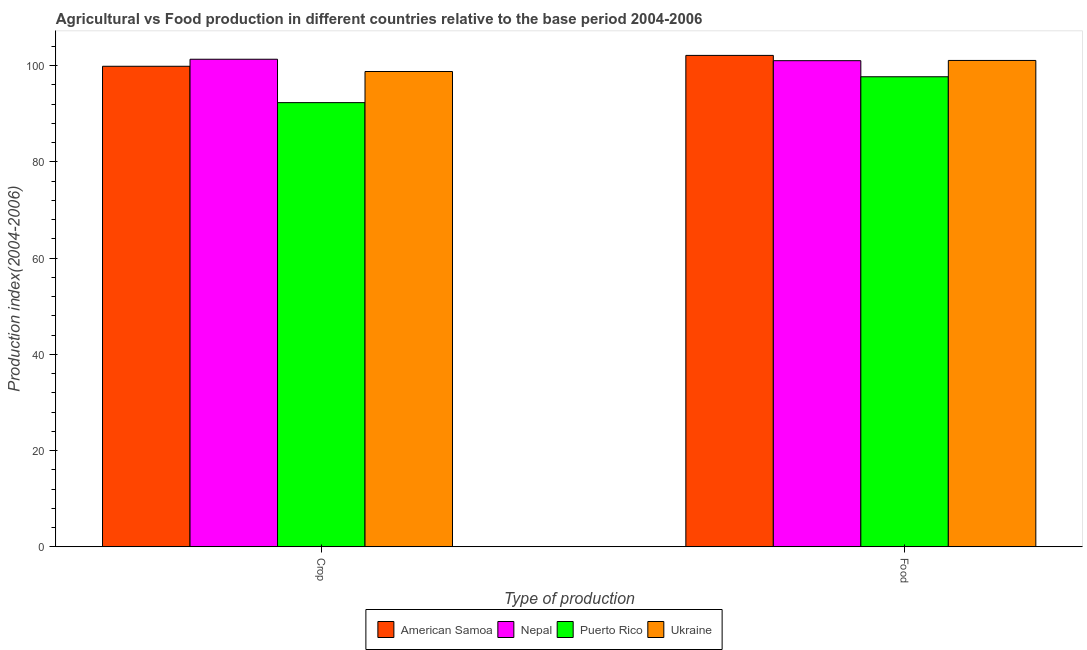How many different coloured bars are there?
Keep it short and to the point. 4. Are the number of bars per tick equal to the number of legend labels?
Your answer should be very brief. Yes. Are the number of bars on each tick of the X-axis equal?
Ensure brevity in your answer.  Yes. What is the label of the 1st group of bars from the left?
Ensure brevity in your answer.  Crop. What is the crop production index in Ukraine?
Offer a very short reply. 98.78. Across all countries, what is the maximum crop production index?
Provide a succinct answer. 101.33. Across all countries, what is the minimum crop production index?
Provide a short and direct response. 92.31. In which country was the crop production index maximum?
Provide a short and direct response. Nepal. In which country was the crop production index minimum?
Your response must be concise. Puerto Rico. What is the total crop production index in the graph?
Keep it short and to the point. 392.29. What is the difference between the crop production index in Nepal and that in Ukraine?
Offer a terse response. 2.55. What is the difference between the food production index in American Samoa and the crop production index in Puerto Rico?
Your response must be concise. 9.82. What is the average food production index per country?
Make the answer very short. 100.48. What is the difference between the crop production index and food production index in Nepal?
Provide a succinct answer. 0.3. In how many countries, is the food production index greater than 52 ?
Provide a succinct answer. 4. What is the ratio of the food production index in Nepal to that in Puerto Rico?
Your answer should be compact. 1.03. What does the 4th bar from the left in Food represents?
Offer a terse response. Ukraine. What does the 3rd bar from the right in Crop represents?
Give a very brief answer. Nepal. How many bars are there?
Ensure brevity in your answer.  8. Are all the bars in the graph horizontal?
Offer a very short reply. No. What is the difference between two consecutive major ticks on the Y-axis?
Provide a short and direct response. 20. Does the graph contain any zero values?
Make the answer very short. No. Does the graph contain grids?
Offer a very short reply. No. How many legend labels are there?
Keep it short and to the point. 4. How are the legend labels stacked?
Ensure brevity in your answer.  Horizontal. What is the title of the graph?
Ensure brevity in your answer.  Agricultural vs Food production in different countries relative to the base period 2004-2006. Does "Guyana" appear as one of the legend labels in the graph?
Make the answer very short. No. What is the label or title of the X-axis?
Ensure brevity in your answer.  Type of production. What is the label or title of the Y-axis?
Offer a terse response. Production index(2004-2006). What is the Production index(2004-2006) in American Samoa in Crop?
Offer a terse response. 99.87. What is the Production index(2004-2006) in Nepal in Crop?
Offer a very short reply. 101.33. What is the Production index(2004-2006) of Puerto Rico in Crop?
Your response must be concise. 92.31. What is the Production index(2004-2006) of Ukraine in Crop?
Offer a very short reply. 98.78. What is the Production index(2004-2006) of American Samoa in Food?
Make the answer very short. 102.13. What is the Production index(2004-2006) of Nepal in Food?
Offer a very short reply. 101.03. What is the Production index(2004-2006) in Puerto Rico in Food?
Provide a succinct answer. 97.69. What is the Production index(2004-2006) in Ukraine in Food?
Offer a terse response. 101.08. Across all Type of production, what is the maximum Production index(2004-2006) of American Samoa?
Offer a very short reply. 102.13. Across all Type of production, what is the maximum Production index(2004-2006) of Nepal?
Give a very brief answer. 101.33. Across all Type of production, what is the maximum Production index(2004-2006) in Puerto Rico?
Offer a very short reply. 97.69. Across all Type of production, what is the maximum Production index(2004-2006) in Ukraine?
Your response must be concise. 101.08. Across all Type of production, what is the minimum Production index(2004-2006) of American Samoa?
Offer a terse response. 99.87. Across all Type of production, what is the minimum Production index(2004-2006) in Nepal?
Your answer should be very brief. 101.03. Across all Type of production, what is the minimum Production index(2004-2006) in Puerto Rico?
Give a very brief answer. 92.31. Across all Type of production, what is the minimum Production index(2004-2006) of Ukraine?
Offer a very short reply. 98.78. What is the total Production index(2004-2006) in American Samoa in the graph?
Make the answer very short. 202. What is the total Production index(2004-2006) of Nepal in the graph?
Provide a succinct answer. 202.36. What is the total Production index(2004-2006) of Puerto Rico in the graph?
Provide a succinct answer. 190. What is the total Production index(2004-2006) in Ukraine in the graph?
Give a very brief answer. 199.86. What is the difference between the Production index(2004-2006) of American Samoa in Crop and that in Food?
Offer a very short reply. -2.26. What is the difference between the Production index(2004-2006) of Nepal in Crop and that in Food?
Offer a very short reply. 0.3. What is the difference between the Production index(2004-2006) in Puerto Rico in Crop and that in Food?
Your response must be concise. -5.38. What is the difference between the Production index(2004-2006) in American Samoa in Crop and the Production index(2004-2006) in Nepal in Food?
Offer a terse response. -1.16. What is the difference between the Production index(2004-2006) in American Samoa in Crop and the Production index(2004-2006) in Puerto Rico in Food?
Ensure brevity in your answer.  2.18. What is the difference between the Production index(2004-2006) in American Samoa in Crop and the Production index(2004-2006) in Ukraine in Food?
Offer a terse response. -1.21. What is the difference between the Production index(2004-2006) of Nepal in Crop and the Production index(2004-2006) of Puerto Rico in Food?
Your response must be concise. 3.64. What is the difference between the Production index(2004-2006) in Puerto Rico in Crop and the Production index(2004-2006) in Ukraine in Food?
Your answer should be very brief. -8.77. What is the average Production index(2004-2006) in American Samoa per Type of production?
Provide a succinct answer. 101. What is the average Production index(2004-2006) of Nepal per Type of production?
Provide a succinct answer. 101.18. What is the average Production index(2004-2006) of Puerto Rico per Type of production?
Make the answer very short. 95. What is the average Production index(2004-2006) in Ukraine per Type of production?
Offer a terse response. 99.93. What is the difference between the Production index(2004-2006) in American Samoa and Production index(2004-2006) in Nepal in Crop?
Offer a terse response. -1.46. What is the difference between the Production index(2004-2006) in American Samoa and Production index(2004-2006) in Puerto Rico in Crop?
Your response must be concise. 7.56. What is the difference between the Production index(2004-2006) in American Samoa and Production index(2004-2006) in Ukraine in Crop?
Your answer should be very brief. 1.09. What is the difference between the Production index(2004-2006) of Nepal and Production index(2004-2006) of Puerto Rico in Crop?
Make the answer very short. 9.02. What is the difference between the Production index(2004-2006) in Nepal and Production index(2004-2006) in Ukraine in Crop?
Provide a short and direct response. 2.55. What is the difference between the Production index(2004-2006) of Puerto Rico and Production index(2004-2006) of Ukraine in Crop?
Provide a short and direct response. -6.47. What is the difference between the Production index(2004-2006) of American Samoa and Production index(2004-2006) of Puerto Rico in Food?
Give a very brief answer. 4.44. What is the difference between the Production index(2004-2006) in Nepal and Production index(2004-2006) in Puerto Rico in Food?
Your response must be concise. 3.34. What is the difference between the Production index(2004-2006) of Nepal and Production index(2004-2006) of Ukraine in Food?
Give a very brief answer. -0.05. What is the difference between the Production index(2004-2006) of Puerto Rico and Production index(2004-2006) of Ukraine in Food?
Offer a terse response. -3.39. What is the ratio of the Production index(2004-2006) of American Samoa in Crop to that in Food?
Offer a very short reply. 0.98. What is the ratio of the Production index(2004-2006) in Nepal in Crop to that in Food?
Keep it short and to the point. 1. What is the ratio of the Production index(2004-2006) of Puerto Rico in Crop to that in Food?
Make the answer very short. 0.94. What is the ratio of the Production index(2004-2006) of Ukraine in Crop to that in Food?
Offer a terse response. 0.98. What is the difference between the highest and the second highest Production index(2004-2006) of American Samoa?
Your answer should be very brief. 2.26. What is the difference between the highest and the second highest Production index(2004-2006) in Nepal?
Your response must be concise. 0.3. What is the difference between the highest and the second highest Production index(2004-2006) of Puerto Rico?
Ensure brevity in your answer.  5.38. What is the difference between the highest and the second highest Production index(2004-2006) of Ukraine?
Offer a terse response. 2.3. What is the difference between the highest and the lowest Production index(2004-2006) of American Samoa?
Your response must be concise. 2.26. What is the difference between the highest and the lowest Production index(2004-2006) in Nepal?
Give a very brief answer. 0.3. What is the difference between the highest and the lowest Production index(2004-2006) of Puerto Rico?
Your answer should be compact. 5.38. 